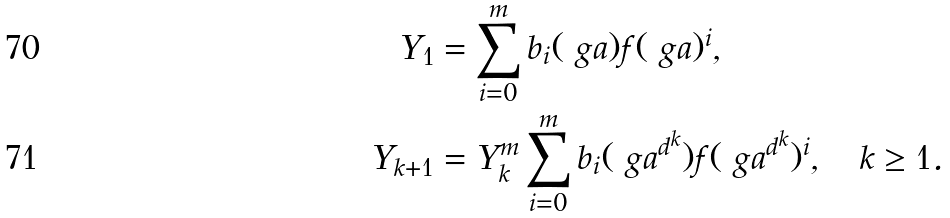<formula> <loc_0><loc_0><loc_500><loc_500>Y _ { 1 } & = \sum _ { i = 0 } ^ { m } b _ { i } ( \ g a ) f ( \ g a ) ^ { i } , \\ Y _ { k + 1 } & = Y _ { k } ^ { m } \sum _ { i = 0 } ^ { m } b _ { i } ( \ g a ^ { d ^ { k } } ) f ( \ g a ^ { d ^ { k } } ) ^ { i } , \quad k \geq 1 .</formula> 